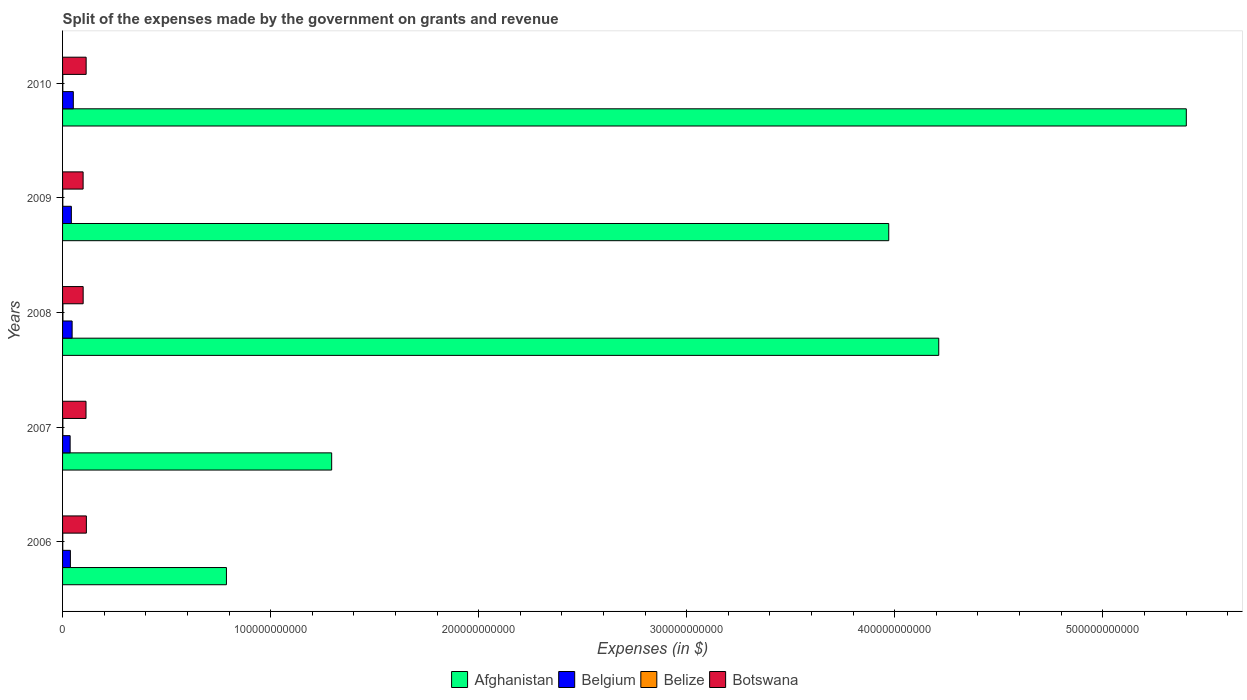How many different coloured bars are there?
Make the answer very short. 4. How many groups of bars are there?
Give a very brief answer. 5. Are the number of bars per tick equal to the number of legend labels?
Provide a short and direct response. Yes. What is the label of the 4th group of bars from the top?
Ensure brevity in your answer.  2007. In how many cases, is the number of bars for a given year not equal to the number of legend labels?
Your answer should be very brief. 0. What is the expenses made by the government on grants and revenue in Botswana in 2010?
Keep it short and to the point. 1.13e+1. Across all years, what is the maximum expenses made by the government on grants and revenue in Afghanistan?
Offer a very short reply. 5.40e+11. Across all years, what is the minimum expenses made by the government on grants and revenue in Belize?
Provide a succinct answer. 9.29e+07. In which year was the expenses made by the government on grants and revenue in Belize maximum?
Make the answer very short. 2008. In which year was the expenses made by the government on grants and revenue in Belize minimum?
Offer a very short reply. 2006. What is the total expenses made by the government on grants and revenue in Botswana in the graph?
Provide a short and direct response. 5.38e+1. What is the difference between the expenses made by the government on grants and revenue in Botswana in 2007 and that in 2008?
Offer a terse response. 1.37e+09. What is the difference between the expenses made by the government on grants and revenue in Belgium in 2008 and the expenses made by the government on grants and revenue in Botswana in 2007?
Keep it short and to the point. -6.68e+09. What is the average expenses made by the government on grants and revenue in Belgium per year?
Offer a terse response. 4.28e+09. In the year 2009, what is the difference between the expenses made by the government on grants and revenue in Belgium and expenses made by the government on grants and revenue in Afghanistan?
Offer a very short reply. -3.93e+11. What is the ratio of the expenses made by the government on grants and revenue in Botswana in 2008 to that in 2010?
Your response must be concise. 0.87. Is the difference between the expenses made by the government on grants and revenue in Belgium in 2006 and 2008 greater than the difference between the expenses made by the government on grants and revenue in Afghanistan in 2006 and 2008?
Keep it short and to the point. Yes. What is the difference between the highest and the second highest expenses made by the government on grants and revenue in Belize?
Provide a succinct answer. 3.06e+07. What is the difference between the highest and the lowest expenses made by the government on grants and revenue in Belize?
Offer a terse response. 8.66e+07. Is the sum of the expenses made by the government on grants and revenue in Botswana in 2009 and 2010 greater than the maximum expenses made by the government on grants and revenue in Afghanistan across all years?
Keep it short and to the point. No. Is it the case that in every year, the sum of the expenses made by the government on grants and revenue in Afghanistan and expenses made by the government on grants and revenue in Belgium is greater than the sum of expenses made by the government on grants and revenue in Botswana and expenses made by the government on grants and revenue in Belize?
Keep it short and to the point. No. What does the 2nd bar from the bottom in 2009 represents?
Your answer should be compact. Belgium. How many bars are there?
Keep it short and to the point. 20. Are all the bars in the graph horizontal?
Offer a terse response. Yes. How many years are there in the graph?
Ensure brevity in your answer.  5. What is the difference between two consecutive major ticks on the X-axis?
Make the answer very short. 1.00e+11. Does the graph contain any zero values?
Provide a succinct answer. No. Where does the legend appear in the graph?
Provide a short and direct response. Bottom center. How many legend labels are there?
Give a very brief answer. 4. How are the legend labels stacked?
Keep it short and to the point. Horizontal. What is the title of the graph?
Ensure brevity in your answer.  Split of the expenses made by the government on grants and revenue. What is the label or title of the X-axis?
Your answer should be very brief. Expenses (in $). What is the Expenses (in $) of Afghanistan in 2006?
Your answer should be very brief. 7.88e+1. What is the Expenses (in $) of Belgium in 2006?
Your answer should be compact. 3.76e+09. What is the Expenses (in $) of Belize in 2006?
Ensure brevity in your answer.  9.29e+07. What is the Expenses (in $) of Botswana in 2006?
Provide a short and direct response. 1.14e+1. What is the Expenses (in $) of Afghanistan in 2007?
Make the answer very short. 1.29e+11. What is the Expenses (in $) of Belgium in 2007?
Offer a terse response. 3.64e+09. What is the Expenses (in $) of Belize in 2007?
Provide a succinct answer. 1.49e+08. What is the Expenses (in $) in Botswana in 2007?
Offer a very short reply. 1.13e+1. What is the Expenses (in $) in Afghanistan in 2008?
Your response must be concise. 4.21e+11. What is the Expenses (in $) of Belgium in 2008?
Give a very brief answer. 4.59e+09. What is the Expenses (in $) of Belize in 2008?
Offer a very short reply. 1.80e+08. What is the Expenses (in $) of Botswana in 2008?
Keep it short and to the point. 9.89e+09. What is the Expenses (in $) in Afghanistan in 2009?
Offer a very short reply. 3.97e+11. What is the Expenses (in $) in Belgium in 2009?
Your answer should be compact. 4.23e+09. What is the Expenses (in $) in Belize in 2009?
Make the answer very short. 1.15e+08. What is the Expenses (in $) of Botswana in 2009?
Give a very brief answer. 9.87e+09. What is the Expenses (in $) in Afghanistan in 2010?
Your answer should be compact. 5.40e+11. What is the Expenses (in $) of Belgium in 2010?
Give a very brief answer. 5.17e+09. What is the Expenses (in $) in Belize in 2010?
Keep it short and to the point. 1.19e+08. What is the Expenses (in $) in Botswana in 2010?
Keep it short and to the point. 1.13e+1. Across all years, what is the maximum Expenses (in $) in Afghanistan?
Keep it short and to the point. 5.40e+11. Across all years, what is the maximum Expenses (in $) in Belgium?
Provide a short and direct response. 5.17e+09. Across all years, what is the maximum Expenses (in $) of Belize?
Provide a succinct answer. 1.80e+08. Across all years, what is the maximum Expenses (in $) of Botswana?
Ensure brevity in your answer.  1.14e+1. Across all years, what is the minimum Expenses (in $) in Afghanistan?
Your answer should be compact. 7.88e+1. Across all years, what is the minimum Expenses (in $) in Belgium?
Make the answer very short. 3.64e+09. Across all years, what is the minimum Expenses (in $) in Belize?
Ensure brevity in your answer.  9.29e+07. Across all years, what is the minimum Expenses (in $) of Botswana?
Keep it short and to the point. 9.87e+09. What is the total Expenses (in $) of Afghanistan in the graph?
Provide a short and direct response. 1.57e+12. What is the total Expenses (in $) of Belgium in the graph?
Your response must be concise. 2.14e+1. What is the total Expenses (in $) in Belize in the graph?
Your answer should be compact. 6.55e+08. What is the total Expenses (in $) in Botswana in the graph?
Your answer should be compact. 5.38e+1. What is the difference between the Expenses (in $) in Afghanistan in 2006 and that in 2007?
Your answer should be very brief. -5.06e+1. What is the difference between the Expenses (in $) of Belgium in 2006 and that in 2007?
Your answer should be compact. 1.22e+08. What is the difference between the Expenses (in $) in Belize in 2006 and that in 2007?
Provide a short and direct response. -5.60e+07. What is the difference between the Expenses (in $) of Botswana in 2006 and that in 2007?
Your answer should be compact. 1.78e+08. What is the difference between the Expenses (in $) in Afghanistan in 2006 and that in 2008?
Ensure brevity in your answer.  -3.42e+11. What is the difference between the Expenses (in $) in Belgium in 2006 and that in 2008?
Give a very brief answer. -8.29e+08. What is the difference between the Expenses (in $) of Belize in 2006 and that in 2008?
Ensure brevity in your answer.  -8.66e+07. What is the difference between the Expenses (in $) in Botswana in 2006 and that in 2008?
Your answer should be very brief. 1.55e+09. What is the difference between the Expenses (in $) in Afghanistan in 2006 and that in 2009?
Ensure brevity in your answer.  -3.18e+11. What is the difference between the Expenses (in $) in Belgium in 2006 and that in 2009?
Give a very brief answer. -4.64e+08. What is the difference between the Expenses (in $) of Belize in 2006 and that in 2009?
Offer a terse response. -2.22e+07. What is the difference between the Expenses (in $) of Botswana in 2006 and that in 2009?
Make the answer very short. 1.57e+09. What is the difference between the Expenses (in $) of Afghanistan in 2006 and that in 2010?
Give a very brief answer. -4.61e+11. What is the difference between the Expenses (in $) in Belgium in 2006 and that in 2010?
Your response must be concise. -1.40e+09. What is the difference between the Expenses (in $) of Belize in 2006 and that in 2010?
Offer a terse response. -2.60e+07. What is the difference between the Expenses (in $) in Botswana in 2006 and that in 2010?
Offer a very short reply. 1.12e+08. What is the difference between the Expenses (in $) of Afghanistan in 2007 and that in 2008?
Make the answer very short. -2.92e+11. What is the difference between the Expenses (in $) of Belgium in 2007 and that in 2008?
Offer a terse response. -9.50e+08. What is the difference between the Expenses (in $) in Belize in 2007 and that in 2008?
Keep it short and to the point. -3.06e+07. What is the difference between the Expenses (in $) in Botswana in 2007 and that in 2008?
Provide a short and direct response. 1.37e+09. What is the difference between the Expenses (in $) in Afghanistan in 2007 and that in 2009?
Offer a very short reply. -2.68e+11. What is the difference between the Expenses (in $) of Belgium in 2007 and that in 2009?
Make the answer very short. -5.85e+08. What is the difference between the Expenses (in $) of Belize in 2007 and that in 2009?
Ensure brevity in your answer.  3.38e+07. What is the difference between the Expenses (in $) in Botswana in 2007 and that in 2009?
Provide a succinct answer. 1.39e+09. What is the difference between the Expenses (in $) of Afghanistan in 2007 and that in 2010?
Offer a terse response. -4.11e+11. What is the difference between the Expenses (in $) in Belgium in 2007 and that in 2010?
Give a very brief answer. -1.52e+09. What is the difference between the Expenses (in $) of Belize in 2007 and that in 2010?
Offer a very short reply. 3.00e+07. What is the difference between the Expenses (in $) in Botswana in 2007 and that in 2010?
Offer a terse response. -6.63e+07. What is the difference between the Expenses (in $) in Afghanistan in 2008 and that in 2009?
Offer a very short reply. 2.40e+1. What is the difference between the Expenses (in $) of Belgium in 2008 and that in 2009?
Your answer should be compact. 3.65e+08. What is the difference between the Expenses (in $) of Belize in 2008 and that in 2009?
Keep it short and to the point. 6.44e+07. What is the difference between the Expenses (in $) in Botswana in 2008 and that in 2009?
Ensure brevity in your answer.  1.95e+07. What is the difference between the Expenses (in $) in Afghanistan in 2008 and that in 2010?
Your answer should be very brief. -1.19e+11. What is the difference between the Expenses (in $) in Belgium in 2008 and that in 2010?
Offer a very short reply. -5.74e+08. What is the difference between the Expenses (in $) in Belize in 2008 and that in 2010?
Keep it short and to the point. 6.06e+07. What is the difference between the Expenses (in $) in Botswana in 2008 and that in 2010?
Keep it short and to the point. -1.44e+09. What is the difference between the Expenses (in $) of Afghanistan in 2009 and that in 2010?
Your answer should be compact. -1.43e+11. What is the difference between the Expenses (in $) in Belgium in 2009 and that in 2010?
Your response must be concise. -9.39e+08. What is the difference between the Expenses (in $) in Belize in 2009 and that in 2010?
Provide a succinct answer. -3.87e+06. What is the difference between the Expenses (in $) in Botswana in 2009 and that in 2010?
Your answer should be very brief. -1.46e+09. What is the difference between the Expenses (in $) in Afghanistan in 2006 and the Expenses (in $) in Belgium in 2007?
Ensure brevity in your answer.  7.51e+1. What is the difference between the Expenses (in $) in Afghanistan in 2006 and the Expenses (in $) in Belize in 2007?
Your answer should be compact. 7.86e+1. What is the difference between the Expenses (in $) of Afghanistan in 2006 and the Expenses (in $) of Botswana in 2007?
Provide a short and direct response. 6.75e+1. What is the difference between the Expenses (in $) of Belgium in 2006 and the Expenses (in $) of Belize in 2007?
Give a very brief answer. 3.61e+09. What is the difference between the Expenses (in $) in Belgium in 2006 and the Expenses (in $) in Botswana in 2007?
Give a very brief answer. -7.50e+09. What is the difference between the Expenses (in $) in Belize in 2006 and the Expenses (in $) in Botswana in 2007?
Offer a terse response. -1.12e+1. What is the difference between the Expenses (in $) of Afghanistan in 2006 and the Expenses (in $) of Belgium in 2008?
Your answer should be very brief. 7.42e+1. What is the difference between the Expenses (in $) in Afghanistan in 2006 and the Expenses (in $) in Belize in 2008?
Your response must be concise. 7.86e+1. What is the difference between the Expenses (in $) of Afghanistan in 2006 and the Expenses (in $) of Botswana in 2008?
Give a very brief answer. 6.89e+1. What is the difference between the Expenses (in $) in Belgium in 2006 and the Expenses (in $) in Belize in 2008?
Provide a short and direct response. 3.58e+09. What is the difference between the Expenses (in $) of Belgium in 2006 and the Expenses (in $) of Botswana in 2008?
Your response must be concise. -6.13e+09. What is the difference between the Expenses (in $) in Belize in 2006 and the Expenses (in $) in Botswana in 2008?
Keep it short and to the point. -9.80e+09. What is the difference between the Expenses (in $) of Afghanistan in 2006 and the Expenses (in $) of Belgium in 2009?
Give a very brief answer. 7.45e+1. What is the difference between the Expenses (in $) of Afghanistan in 2006 and the Expenses (in $) of Belize in 2009?
Your answer should be very brief. 7.87e+1. What is the difference between the Expenses (in $) of Afghanistan in 2006 and the Expenses (in $) of Botswana in 2009?
Provide a succinct answer. 6.89e+1. What is the difference between the Expenses (in $) of Belgium in 2006 and the Expenses (in $) of Belize in 2009?
Keep it short and to the point. 3.65e+09. What is the difference between the Expenses (in $) of Belgium in 2006 and the Expenses (in $) of Botswana in 2009?
Provide a succinct answer. -6.11e+09. What is the difference between the Expenses (in $) in Belize in 2006 and the Expenses (in $) in Botswana in 2009?
Your response must be concise. -9.78e+09. What is the difference between the Expenses (in $) in Afghanistan in 2006 and the Expenses (in $) in Belgium in 2010?
Provide a short and direct response. 7.36e+1. What is the difference between the Expenses (in $) of Afghanistan in 2006 and the Expenses (in $) of Belize in 2010?
Keep it short and to the point. 7.86e+1. What is the difference between the Expenses (in $) of Afghanistan in 2006 and the Expenses (in $) of Botswana in 2010?
Give a very brief answer. 6.74e+1. What is the difference between the Expenses (in $) in Belgium in 2006 and the Expenses (in $) in Belize in 2010?
Offer a very short reply. 3.64e+09. What is the difference between the Expenses (in $) of Belgium in 2006 and the Expenses (in $) of Botswana in 2010?
Your answer should be very brief. -7.57e+09. What is the difference between the Expenses (in $) in Belize in 2006 and the Expenses (in $) in Botswana in 2010?
Make the answer very short. -1.12e+1. What is the difference between the Expenses (in $) of Afghanistan in 2007 and the Expenses (in $) of Belgium in 2008?
Keep it short and to the point. 1.25e+11. What is the difference between the Expenses (in $) of Afghanistan in 2007 and the Expenses (in $) of Belize in 2008?
Offer a very short reply. 1.29e+11. What is the difference between the Expenses (in $) in Afghanistan in 2007 and the Expenses (in $) in Botswana in 2008?
Offer a terse response. 1.19e+11. What is the difference between the Expenses (in $) of Belgium in 2007 and the Expenses (in $) of Belize in 2008?
Ensure brevity in your answer.  3.46e+09. What is the difference between the Expenses (in $) in Belgium in 2007 and the Expenses (in $) in Botswana in 2008?
Offer a very short reply. -6.25e+09. What is the difference between the Expenses (in $) in Belize in 2007 and the Expenses (in $) in Botswana in 2008?
Keep it short and to the point. -9.75e+09. What is the difference between the Expenses (in $) in Afghanistan in 2007 and the Expenses (in $) in Belgium in 2009?
Offer a terse response. 1.25e+11. What is the difference between the Expenses (in $) of Afghanistan in 2007 and the Expenses (in $) of Belize in 2009?
Offer a terse response. 1.29e+11. What is the difference between the Expenses (in $) of Afghanistan in 2007 and the Expenses (in $) of Botswana in 2009?
Provide a succinct answer. 1.19e+11. What is the difference between the Expenses (in $) in Belgium in 2007 and the Expenses (in $) in Belize in 2009?
Your answer should be very brief. 3.53e+09. What is the difference between the Expenses (in $) in Belgium in 2007 and the Expenses (in $) in Botswana in 2009?
Your response must be concise. -6.23e+09. What is the difference between the Expenses (in $) of Belize in 2007 and the Expenses (in $) of Botswana in 2009?
Your response must be concise. -9.73e+09. What is the difference between the Expenses (in $) in Afghanistan in 2007 and the Expenses (in $) in Belgium in 2010?
Provide a short and direct response. 1.24e+11. What is the difference between the Expenses (in $) of Afghanistan in 2007 and the Expenses (in $) of Belize in 2010?
Your response must be concise. 1.29e+11. What is the difference between the Expenses (in $) in Afghanistan in 2007 and the Expenses (in $) in Botswana in 2010?
Provide a succinct answer. 1.18e+11. What is the difference between the Expenses (in $) of Belgium in 2007 and the Expenses (in $) of Belize in 2010?
Ensure brevity in your answer.  3.52e+09. What is the difference between the Expenses (in $) in Belgium in 2007 and the Expenses (in $) in Botswana in 2010?
Provide a short and direct response. -7.69e+09. What is the difference between the Expenses (in $) in Belize in 2007 and the Expenses (in $) in Botswana in 2010?
Your answer should be very brief. -1.12e+1. What is the difference between the Expenses (in $) of Afghanistan in 2008 and the Expenses (in $) of Belgium in 2009?
Provide a short and direct response. 4.17e+11. What is the difference between the Expenses (in $) of Afghanistan in 2008 and the Expenses (in $) of Belize in 2009?
Your answer should be compact. 4.21e+11. What is the difference between the Expenses (in $) of Afghanistan in 2008 and the Expenses (in $) of Botswana in 2009?
Provide a succinct answer. 4.11e+11. What is the difference between the Expenses (in $) of Belgium in 2008 and the Expenses (in $) of Belize in 2009?
Keep it short and to the point. 4.48e+09. What is the difference between the Expenses (in $) of Belgium in 2008 and the Expenses (in $) of Botswana in 2009?
Provide a succinct answer. -5.28e+09. What is the difference between the Expenses (in $) in Belize in 2008 and the Expenses (in $) in Botswana in 2009?
Your answer should be very brief. -9.69e+09. What is the difference between the Expenses (in $) of Afghanistan in 2008 and the Expenses (in $) of Belgium in 2010?
Offer a terse response. 4.16e+11. What is the difference between the Expenses (in $) in Afghanistan in 2008 and the Expenses (in $) in Belize in 2010?
Your answer should be compact. 4.21e+11. What is the difference between the Expenses (in $) in Afghanistan in 2008 and the Expenses (in $) in Botswana in 2010?
Offer a very short reply. 4.10e+11. What is the difference between the Expenses (in $) of Belgium in 2008 and the Expenses (in $) of Belize in 2010?
Give a very brief answer. 4.47e+09. What is the difference between the Expenses (in $) in Belgium in 2008 and the Expenses (in $) in Botswana in 2010?
Give a very brief answer. -6.74e+09. What is the difference between the Expenses (in $) of Belize in 2008 and the Expenses (in $) of Botswana in 2010?
Ensure brevity in your answer.  -1.12e+1. What is the difference between the Expenses (in $) in Afghanistan in 2009 and the Expenses (in $) in Belgium in 2010?
Give a very brief answer. 3.92e+11. What is the difference between the Expenses (in $) of Afghanistan in 2009 and the Expenses (in $) of Belize in 2010?
Make the answer very short. 3.97e+11. What is the difference between the Expenses (in $) in Afghanistan in 2009 and the Expenses (in $) in Botswana in 2010?
Make the answer very short. 3.86e+11. What is the difference between the Expenses (in $) of Belgium in 2009 and the Expenses (in $) of Belize in 2010?
Your response must be concise. 4.11e+09. What is the difference between the Expenses (in $) in Belgium in 2009 and the Expenses (in $) in Botswana in 2010?
Make the answer very short. -7.11e+09. What is the difference between the Expenses (in $) of Belize in 2009 and the Expenses (in $) of Botswana in 2010?
Your answer should be very brief. -1.12e+1. What is the average Expenses (in $) of Afghanistan per year?
Provide a succinct answer. 3.13e+11. What is the average Expenses (in $) of Belgium per year?
Give a very brief answer. 4.28e+09. What is the average Expenses (in $) of Belize per year?
Offer a very short reply. 1.31e+08. What is the average Expenses (in $) of Botswana per year?
Ensure brevity in your answer.  1.08e+1. In the year 2006, what is the difference between the Expenses (in $) of Afghanistan and Expenses (in $) of Belgium?
Offer a terse response. 7.50e+1. In the year 2006, what is the difference between the Expenses (in $) of Afghanistan and Expenses (in $) of Belize?
Give a very brief answer. 7.87e+1. In the year 2006, what is the difference between the Expenses (in $) of Afghanistan and Expenses (in $) of Botswana?
Your answer should be very brief. 6.73e+1. In the year 2006, what is the difference between the Expenses (in $) in Belgium and Expenses (in $) in Belize?
Your answer should be very brief. 3.67e+09. In the year 2006, what is the difference between the Expenses (in $) of Belgium and Expenses (in $) of Botswana?
Your response must be concise. -7.68e+09. In the year 2006, what is the difference between the Expenses (in $) in Belize and Expenses (in $) in Botswana?
Ensure brevity in your answer.  -1.14e+1. In the year 2007, what is the difference between the Expenses (in $) in Afghanistan and Expenses (in $) in Belgium?
Offer a terse response. 1.26e+11. In the year 2007, what is the difference between the Expenses (in $) of Afghanistan and Expenses (in $) of Belize?
Make the answer very short. 1.29e+11. In the year 2007, what is the difference between the Expenses (in $) of Afghanistan and Expenses (in $) of Botswana?
Your answer should be very brief. 1.18e+11. In the year 2007, what is the difference between the Expenses (in $) in Belgium and Expenses (in $) in Belize?
Offer a very short reply. 3.49e+09. In the year 2007, what is the difference between the Expenses (in $) of Belgium and Expenses (in $) of Botswana?
Make the answer very short. -7.63e+09. In the year 2007, what is the difference between the Expenses (in $) in Belize and Expenses (in $) in Botswana?
Provide a succinct answer. -1.11e+1. In the year 2008, what is the difference between the Expenses (in $) of Afghanistan and Expenses (in $) of Belgium?
Provide a succinct answer. 4.17e+11. In the year 2008, what is the difference between the Expenses (in $) in Afghanistan and Expenses (in $) in Belize?
Your answer should be very brief. 4.21e+11. In the year 2008, what is the difference between the Expenses (in $) of Afghanistan and Expenses (in $) of Botswana?
Your response must be concise. 4.11e+11. In the year 2008, what is the difference between the Expenses (in $) in Belgium and Expenses (in $) in Belize?
Offer a very short reply. 4.41e+09. In the year 2008, what is the difference between the Expenses (in $) of Belgium and Expenses (in $) of Botswana?
Offer a terse response. -5.30e+09. In the year 2008, what is the difference between the Expenses (in $) of Belize and Expenses (in $) of Botswana?
Offer a very short reply. -9.71e+09. In the year 2009, what is the difference between the Expenses (in $) in Afghanistan and Expenses (in $) in Belgium?
Your answer should be very brief. 3.93e+11. In the year 2009, what is the difference between the Expenses (in $) in Afghanistan and Expenses (in $) in Belize?
Ensure brevity in your answer.  3.97e+11. In the year 2009, what is the difference between the Expenses (in $) of Afghanistan and Expenses (in $) of Botswana?
Provide a short and direct response. 3.87e+11. In the year 2009, what is the difference between the Expenses (in $) of Belgium and Expenses (in $) of Belize?
Your answer should be very brief. 4.11e+09. In the year 2009, what is the difference between the Expenses (in $) in Belgium and Expenses (in $) in Botswana?
Provide a succinct answer. -5.65e+09. In the year 2009, what is the difference between the Expenses (in $) in Belize and Expenses (in $) in Botswana?
Give a very brief answer. -9.76e+09. In the year 2010, what is the difference between the Expenses (in $) of Afghanistan and Expenses (in $) of Belgium?
Ensure brevity in your answer.  5.35e+11. In the year 2010, what is the difference between the Expenses (in $) of Afghanistan and Expenses (in $) of Belize?
Your answer should be very brief. 5.40e+11. In the year 2010, what is the difference between the Expenses (in $) in Afghanistan and Expenses (in $) in Botswana?
Your response must be concise. 5.29e+11. In the year 2010, what is the difference between the Expenses (in $) of Belgium and Expenses (in $) of Belize?
Your response must be concise. 5.05e+09. In the year 2010, what is the difference between the Expenses (in $) in Belgium and Expenses (in $) in Botswana?
Offer a terse response. -6.17e+09. In the year 2010, what is the difference between the Expenses (in $) in Belize and Expenses (in $) in Botswana?
Offer a terse response. -1.12e+1. What is the ratio of the Expenses (in $) in Afghanistan in 2006 to that in 2007?
Your response must be concise. 0.61. What is the ratio of the Expenses (in $) of Belgium in 2006 to that in 2007?
Offer a very short reply. 1.03. What is the ratio of the Expenses (in $) of Belize in 2006 to that in 2007?
Your response must be concise. 0.62. What is the ratio of the Expenses (in $) of Botswana in 2006 to that in 2007?
Offer a very short reply. 1.02. What is the ratio of the Expenses (in $) in Afghanistan in 2006 to that in 2008?
Offer a very short reply. 0.19. What is the ratio of the Expenses (in $) of Belgium in 2006 to that in 2008?
Provide a short and direct response. 0.82. What is the ratio of the Expenses (in $) of Belize in 2006 to that in 2008?
Keep it short and to the point. 0.52. What is the ratio of the Expenses (in $) in Botswana in 2006 to that in 2008?
Ensure brevity in your answer.  1.16. What is the ratio of the Expenses (in $) in Afghanistan in 2006 to that in 2009?
Your response must be concise. 0.2. What is the ratio of the Expenses (in $) of Belgium in 2006 to that in 2009?
Provide a short and direct response. 0.89. What is the ratio of the Expenses (in $) of Belize in 2006 to that in 2009?
Offer a terse response. 0.81. What is the ratio of the Expenses (in $) in Botswana in 2006 to that in 2009?
Offer a very short reply. 1.16. What is the ratio of the Expenses (in $) in Afghanistan in 2006 to that in 2010?
Your answer should be very brief. 0.15. What is the ratio of the Expenses (in $) of Belgium in 2006 to that in 2010?
Keep it short and to the point. 0.73. What is the ratio of the Expenses (in $) of Belize in 2006 to that in 2010?
Your answer should be compact. 0.78. What is the ratio of the Expenses (in $) of Botswana in 2006 to that in 2010?
Your answer should be very brief. 1.01. What is the ratio of the Expenses (in $) in Afghanistan in 2007 to that in 2008?
Ensure brevity in your answer.  0.31. What is the ratio of the Expenses (in $) in Belgium in 2007 to that in 2008?
Offer a very short reply. 0.79. What is the ratio of the Expenses (in $) of Belize in 2007 to that in 2008?
Your answer should be compact. 0.83. What is the ratio of the Expenses (in $) in Botswana in 2007 to that in 2008?
Provide a succinct answer. 1.14. What is the ratio of the Expenses (in $) in Afghanistan in 2007 to that in 2009?
Provide a succinct answer. 0.33. What is the ratio of the Expenses (in $) of Belgium in 2007 to that in 2009?
Provide a short and direct response. 0.86. What is the ratio of the Expenses (in $) in Belize in 2007 to that in 2009?
Give a very brief answer. 1.29. What is the ratio of the Expenses (in $) of Botswana in 2007 to that in 2009?
Make the answer very short. 1.14. What is the ratio of the Expenses (in $) of Afghanistan in 2007 to that in 2010?
Ensure brevity in your answer.  0.24. What is the ratio of the Expenses (in $) of Belgium in 2007 to that in 2010?
Offer a terse response. 0.7. What is the ratio of the Expenses (in $) in Belize in 2007 to that in 2010?
Offer a very short reply. 1.25. What is the ratio of the Expenses (in $) of Afghanistan in 2008 to that in 2009?
Make the answer very short. 1.06. What is the ratio of the Expenses (in $) of Belgium in 2008 to that in 2009?
Provide a succinct answer. 1.09. What is the ratio of the Expenses (in $) of Belize in 2008 to that in 2009?
Keep it short and to the point. 1.56. What is the ratio of the Expenses (in $) in Botswana in 2008 to that in 2009?
Keep it short and to the point. 1. What is the ratio of the Expenses (in $) of Afghanistan in 2008 to that in 2010?
Your answer should be very brief. 0.78. What is the ratio of the Expenses (in $) of Belgium in 2008 to that in 2010?
Keep it short and to the point. 0.89. What is the ratio of the Expenses (in $) in Belize in 2008 to that in 2010?
Ensure brevity in your answer.  1.51. What is the ratio of the Expenses (in $) in Botswana in 2008 to that in 2010?
Your response must be concise. 0.87. What is the ratio of the Expenses (in $) in Afghanistan in 2009 to that in 2010?
Provide a succinct answer. 0.74. What is the ratio of the Expenses (in $) of Belgium in 2009 to that in 2010?
Make the answer very short. 0.82. What is the ratio of the Expenses (in $) in Belize in 2009 to that in 2010?
Provide a short and direct response. 0.97. What is the ratio of the Expenses (in $) in Botswana in 2009 to that in 2010?
Your response must be concise. 0.87. What is the difference between the highest and the second highest Expenses (in $) in Afghanistan?
Offer a very short reply. 1.19e+11. What is the difference between the highest and the second highest Expenses (in $) in Belgium?
Provide a short and direct response. 5.74e+08. What is the difference between the highest and the second highest Expenses (in $) in Belize?
Ensure brevity in your answer.  3.06e+07. What is the difference between the highest and the second highest Expenses (in $) in Botswana?
Provide a short and direct response. 1.12e+08. What is the difference between the highest and the lowest Expenses (in $) of Afghanistan?
Ensure brevity in your answer.  4.61e+11. What is the difference between the highest and the lowest Expenses (in $) of Belgium?
Offer a terse response. 1.52e+09. What is the difference between the highest and the lowest Expenses (in $) in Belize?
Give a very brief answer. 8.66e+07. What is the difference between the highest and the lowest Expenses (in $) of Botswana?
Your answer should be very brief. 1.57e+09. 